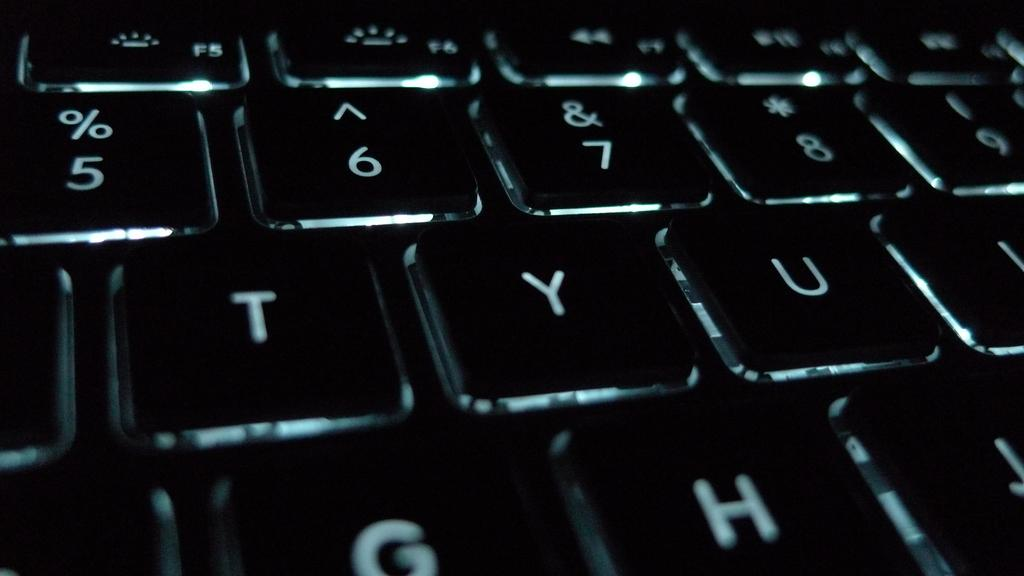<image>
Provide a brief description of the given image. A backlit keyboard with the numbers 5, 6, 7 and the letters T, Y, and U. 